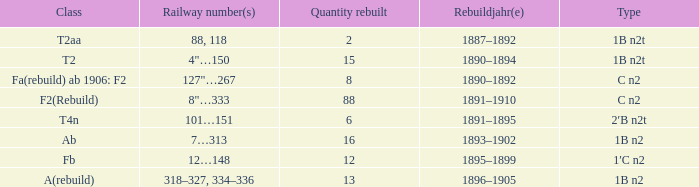What is the overall sum of the rebuilt quantity if the kind is 1b n2t and the train number is 88, 118? 1.0. 